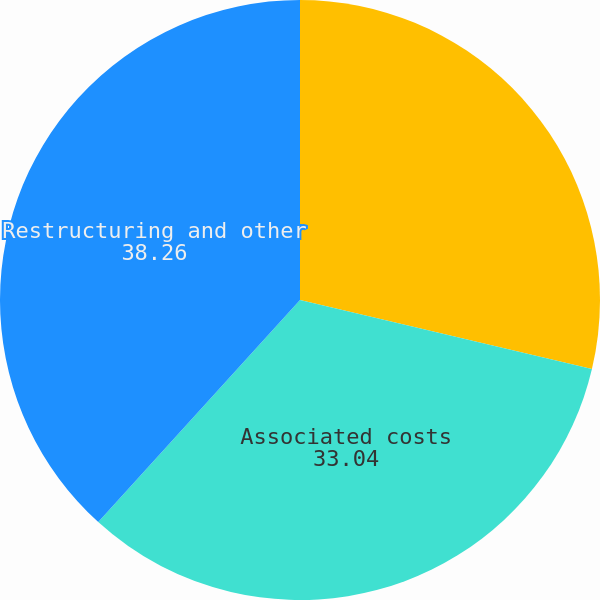Convert chart. <chart><loc_0><loc_0><loc_500><loc_500><pie_chart><fcel>Capital expenditures<fcel>Associated costs<fcel>Restructuring and other<nl><fcel>28.7%<fcel>33.04%<fcel>38.26%<nl></chart> 